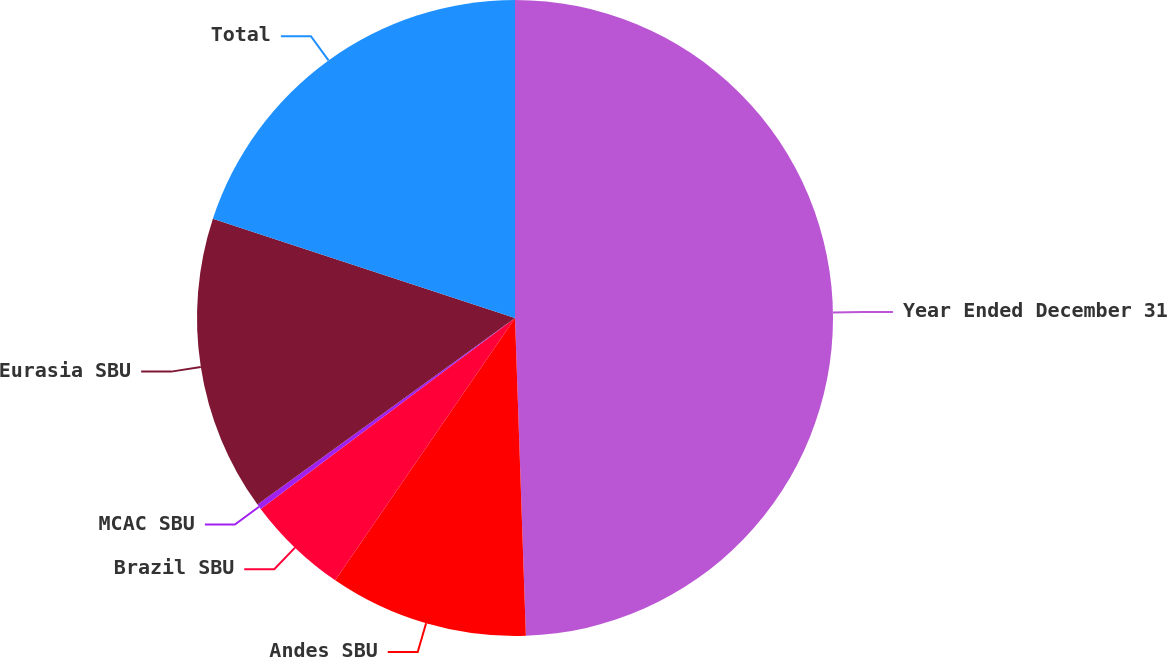Convert chart. <chart><loc_0><loc_0><loc_500><loc_500><pie_chart><fcel>Year Ended December 31<fcel>Andes SBU<fcel>Brazil SBU<fcel>MCAC SBU<fcel>Eurasia SBU<fcel>Total<nl><fcel>49.46%<fcel>10.11%<fcel>5.19%<fcel>0.27%<fcel>15.03%<fcel>19.95%<nl></chart> 